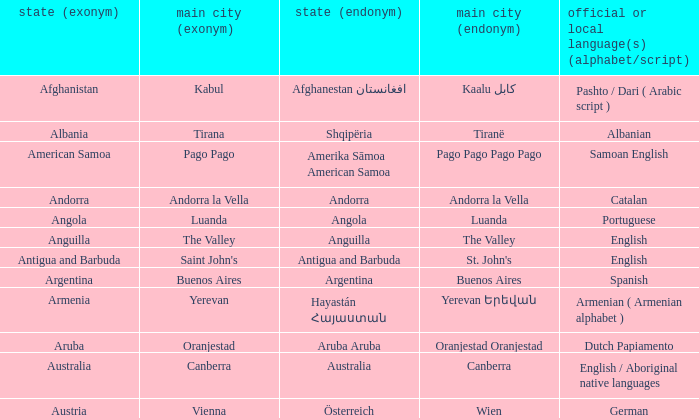What is the local name given to the capital of Anguilla? The Valley. 